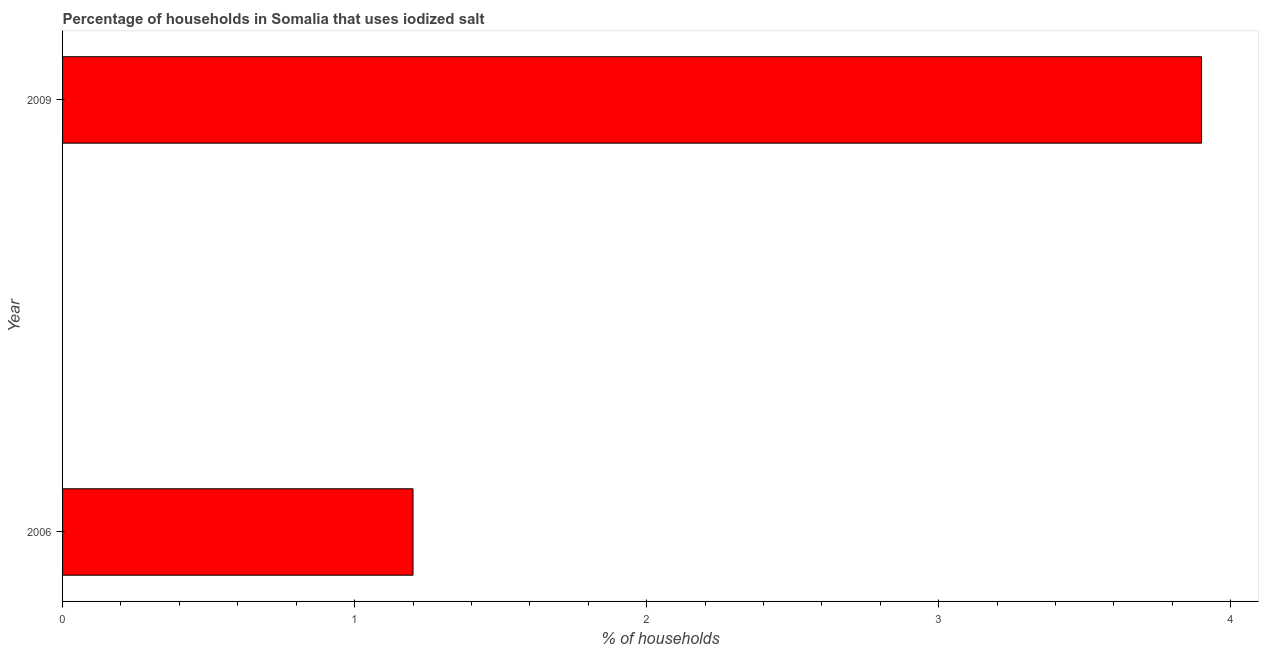What is the title of the graph?
Your response must be concise. Percentage of households in Somalia that uses iodized salt. What is the label or title of the X-axis?
Make the answer very short. % of households. What is the sum of the percentage of households where iodized salt is consumed?
Your answer should be very brief. 5.1. What is the difference between the percentage of households where iodized salt is consumed in 2006 and 2009?
Offer a terse response. -2.7. What is the average percentage of households where iodized salt is consumed per year?
Offer a terse response. 2.55. What is the median percentage of households where iodized salt is consumed?
Offer a terse response. 2.55. Do a majority of the years between 2009 and 2006 (inclusive) have percentage of households where iodized salt is consumed greater than 3 %?
Offer a terse response. No. What is the ratio of the percentage of households where iodized salt is consumed in 2006 to that in 2009?
Make the answer very short. 0.31. Is the percentage of households where iodized salt is consumed in 2006 less than that in 2009?
Your response must be concise. Yes. In how many years, is the percentage of households where iodized salt is consumed greater than the average percentage of households where iodized salt is consumed taken over all years?
Your answer should be compact. 1. How many bars are there?
Provide a short and direct response. 2. How many years are there in the graph?
Offer a terse response. 2. What is the % of households of 2006?
Ensure brevity in your answer.  1.2. What is the % of households in 2009?
Keep it short and to the point. 3.9. What is the difference between the % of households in 2006 and 2009?
Offer a very short reply. -2.7. What is the ratio of the % of households in 2006 to that in 2009?
Ensure brevity in your answer.  0.31. 